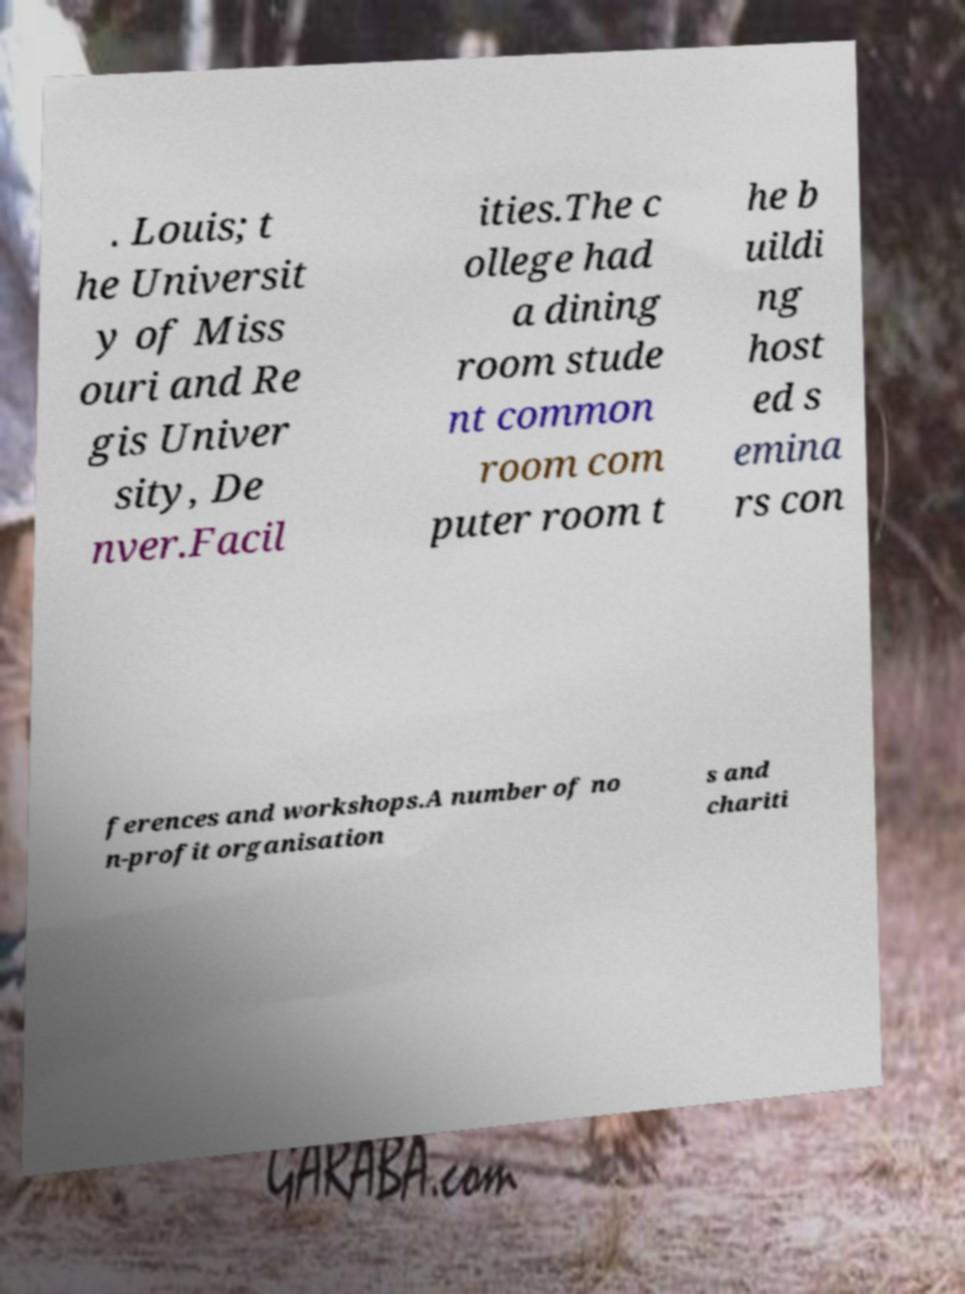Please read and relay the text visible in this image. What does it say? . Louis; t he Universit y of Miss ouri and Re gis Univer sity, De nver.Facil ities.The c ollege had a dining room stude nt common room com puter room t he b uildi ng host ed s emina rs con ferences and workshops.A number of no n-profit organisation s and chariti 